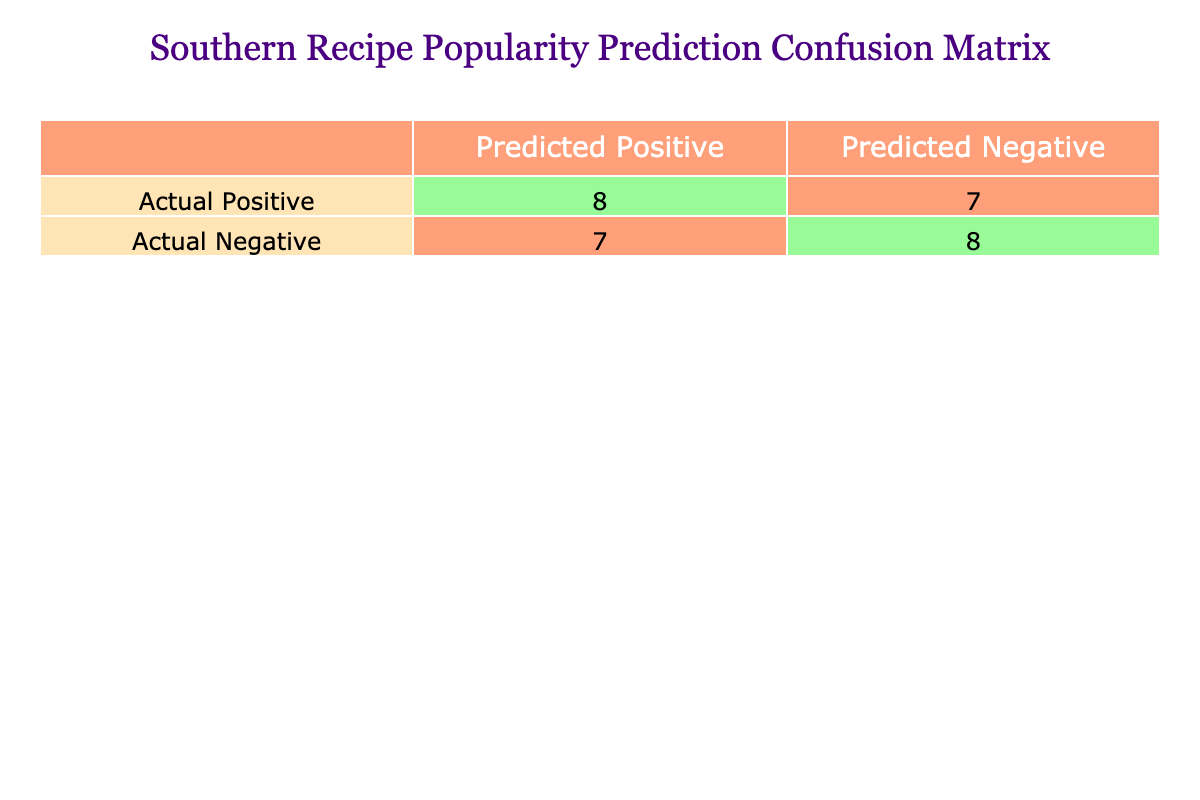What is the total number of true positives? The table indicates that the true positives (actual positive predictions that were correctly identified) are represented in the first cell of the first row. By reviewing the data, it can be seen that Southern Fried Chicken, Shrimp and Grits, Collard Greens, Banana Pudding, Jambalaya, Biscuits and Gravy, Hush Puppies, and Crawfish Etouffee were predicted to be positive correctly, totaling 8.
Answer: 8 What is the total number of false positives? The false positives are indicated in the second cell of the second row of the confusion matrix. From the data provided, the items that were incorrectly predicted as positive include Pecan Pie, Cornbread, BBQ Ribs, and Red Beans and Rice, giving a total count of 4.
Answer: 4 How many total predictions were made? The total predictions can be calculated by adding true positives, false positives, true negatives, and false negatives together. The values reported are 8 true positives, 4 false positives, and looking at the remaining items, we find there are 5 true negatives and 0 false negatives, meaning the total is 8 + 4 + 5 + 0 = 17.
Answer: 17 Are there more true positives than true negatives? True positives from the table amount to 8, while true negatives amount to 5. Since 8 is greater than 5, this statement is true.
Answer: Yes What percentage of the predictions were true positives? To find the percentage of true positives, divide the number of true positives (8) by the total number of predictions (17) and multiply by 100. Thus, (8 / 17) * 100 is approximately 47.06%.
Answer: 47.06% How many recipes were incorrectly predicted as negative? Recipes incorrectly predicted as negative would appear in the second cell of the first row of the table. Only the items that were actual positives but predicted as negatives contribute to this count. As per the data, there are no such items, meaning the false negatives total 0.
Answer: 0 How many more true positives are there compared to false negatives? In this confusion matrix, true positives number 8, and false negatives are 0. To find the difference, subtract the number of false negatives from true positives: 8 - 0 = 8.
Answer: 8 What is the total count of actual negatives? Actual negatives can be identified by checking the second row of the confusion matrix, which indicates the count of true negatives and false positives. From the confusion matrix, true negatives are 5 and false positives are 4, giving a total count of actual negatives as 4 + 5 = 9.
Answer: 9 What fraction of recipes were correctly predicted? The correctly predicted recipes are represented by the sum of true positives and true negatives, which equals 8 + 5 = 13. To find the fraction, divide this by the total predictions of 17: 13 / 17. This fraction represents the portion of correct predictions.
Answer: 13/17 